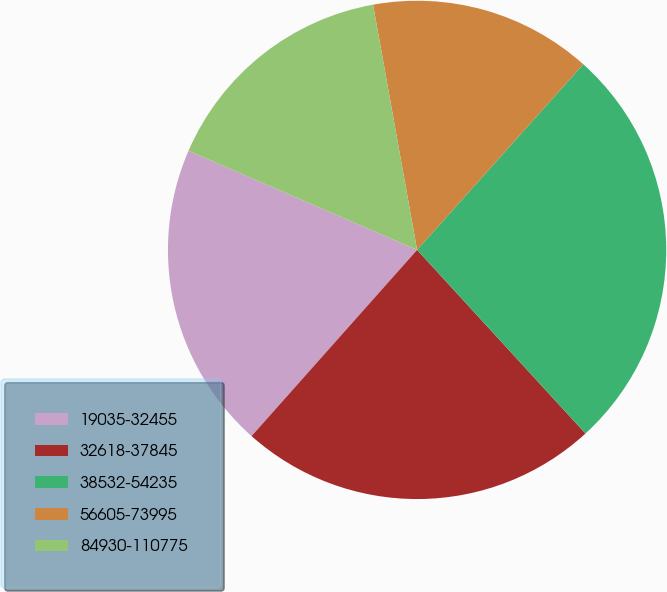Convert chart. <chart><loc_0><loc_0><loc_500><loc_500><pie_chart><fcel>19035-32455<fcel>32618-37845<fcel>38532-54235<fcel>56605-73995<fcel>84930-110775<nl><fcel>19.95%<fcel>23.38%<fcel>26.57%<fcel>14.45%<fcel>15.66%<nl></chart> 